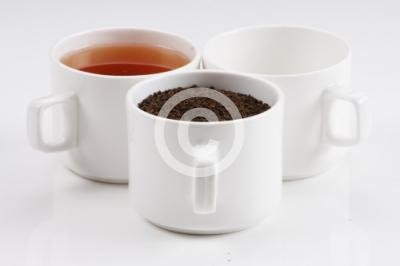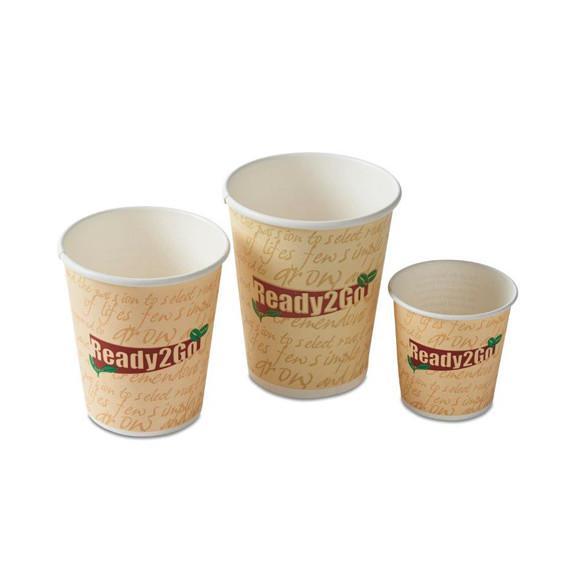The first image is the image on the left, the second image is the image on the right. Examine the images to the left and right. Is the description "There are three cups and three saucers in one of the images." accurate? Answer yes or no. No. The first image is the image on the left, the second image is the image on the right. Examine the images to the left and right. Is the description "An image shows a neat row of three matching cups and saucers." accurate? Answer yes or no. No. 